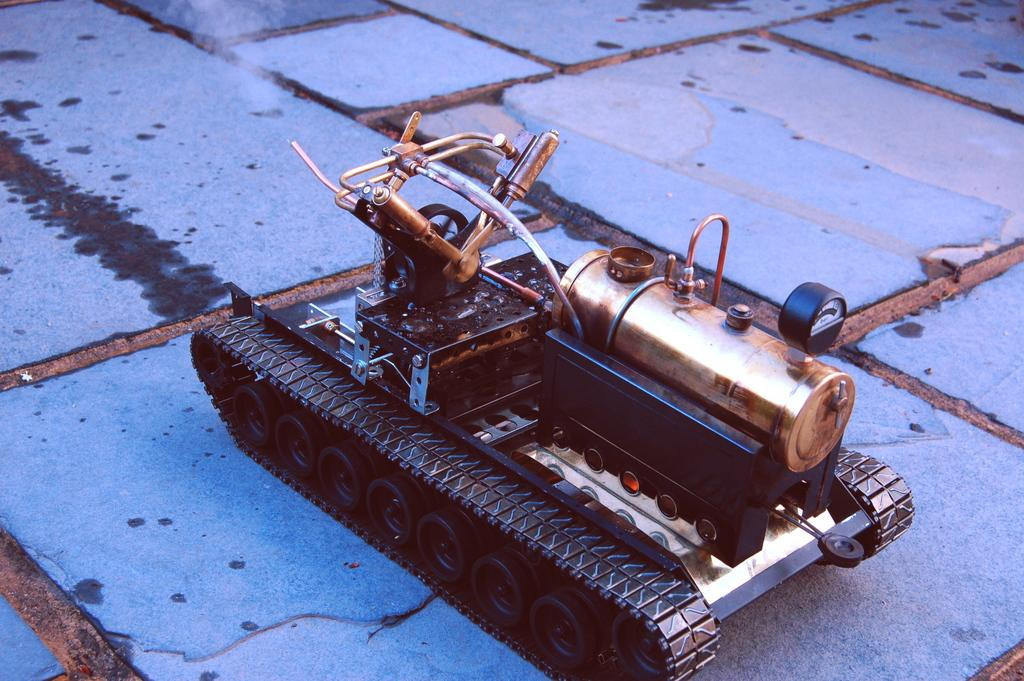What object can be seen in the image? There is a toy in the image. Where is the toy located? The toy is placed on the ground. What feature does the toy have? The toy contains a meter. Can you tell me which country the maid is from in the image? There is no maid present in the image, so it is not possible to determine the country they are from. 